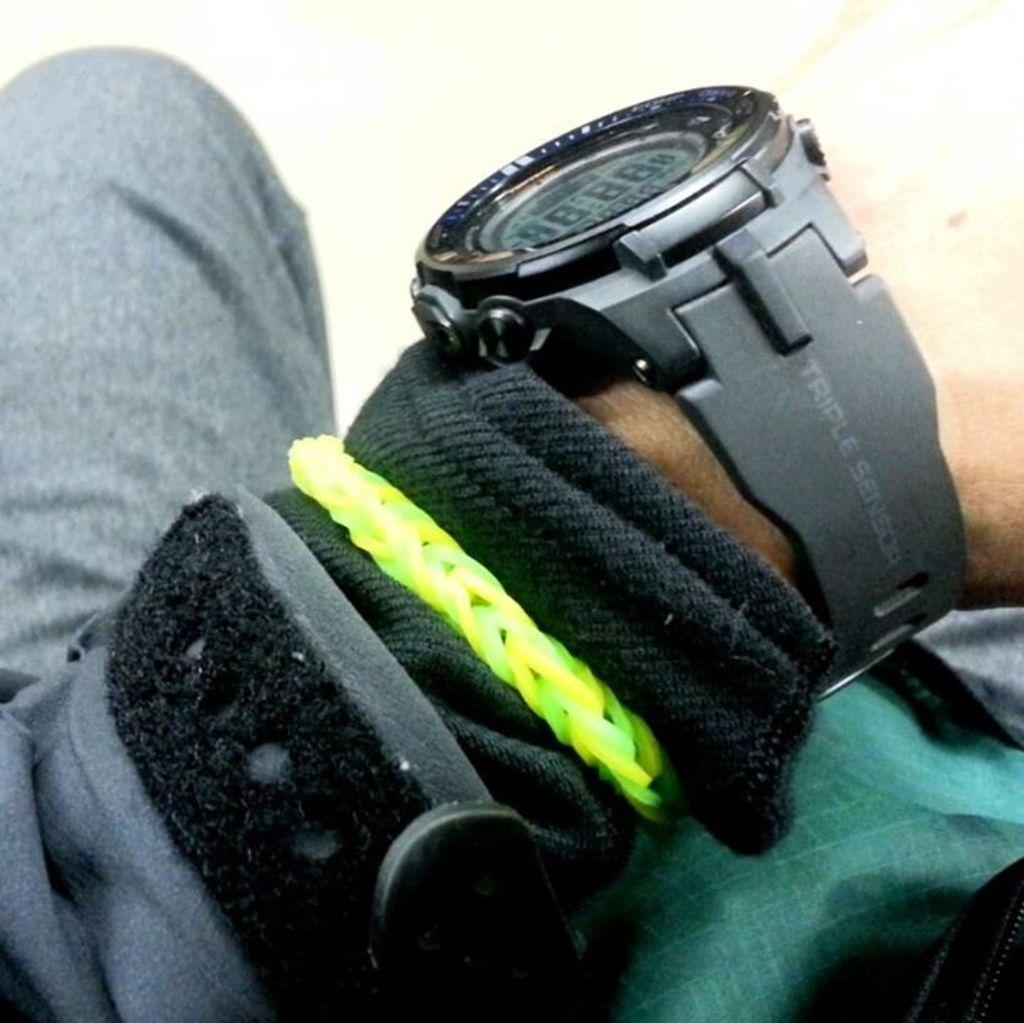<image>
Present a compact description of the photo's key features. View of an arm covered in warm clothing and a watch that reads 'Triple Sensor' on the band. 